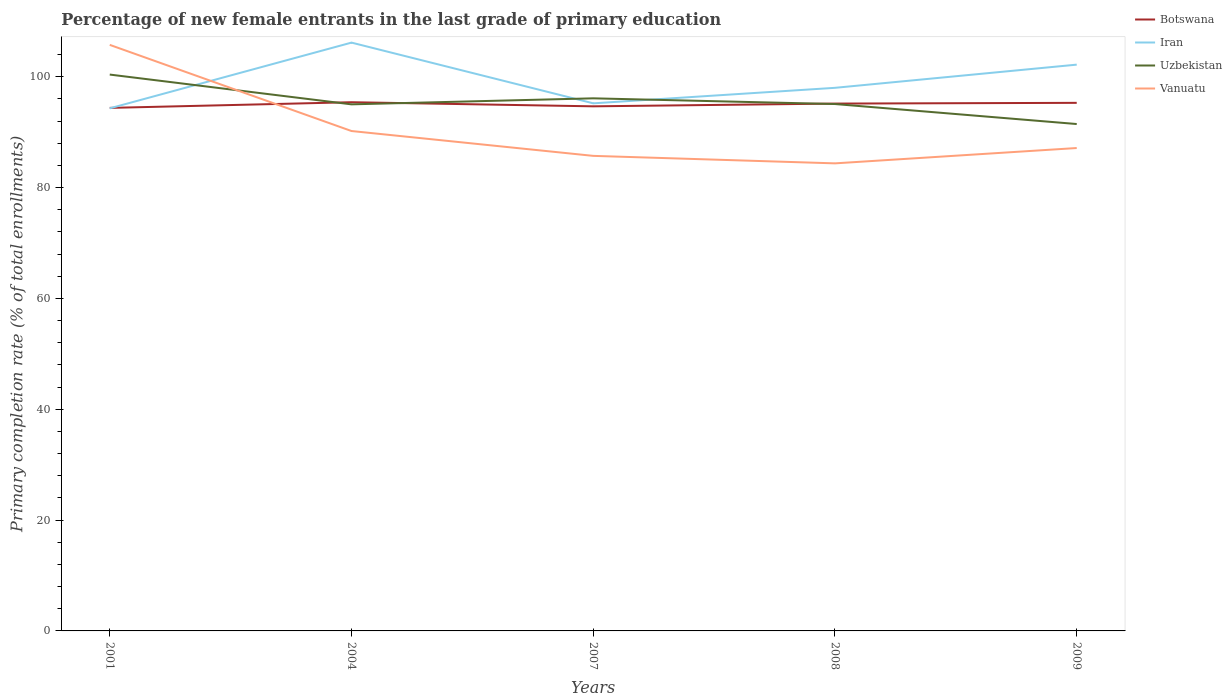Is the number of lines equal to the number of legend labels?
Offer a terse response. Yes. Across all years, what is the maximum percentage of new female entrants in Botswana?
Keep it short and to the point. 94.38. In which year was the percentage of new female entrants in Botswana maximum?
Give a very brief answer. 2001. What is the total percentage of new female entrants in Uzbekistan in the graph?
Your answer should be very brief. -1.09. What is the difference between the highest and the second highest percentage of new female entrants in Vanuatu?
Ensure brevity in your answer.  21.38. What is the difference between the highest and the lowest percentage of new female entrants in Uzbekistan?
Offer a terse response. 2. Is the percentage of new female entrants in Iran strictly greater than the percentage of new female entrants in Botswana over the years?
Make the answer very short. No. What is the difference between two consecutive major ticks on the Y-axis?
Your answer should be very brief. 20. Are the values on the major ticks of Y-axis written in scientific E-notation?
Provide a short and direct response. No. Does the graph contain any zero values?
Give a very brief answer. No. Does the graph contain grids?
Offer a terse response. No. How many legend labels are there?
Offer a terse response. 4. What is the title of the graph?
Provide a short and direct response. Percentage of new female entrants in the last grade of primary education. What is the label or title of the X-axis?
Ensure brevity in your answer.  Years. What is the label or title of the Y-axis?
Provide a short and direct response. Primary completion rate (% of total enrollments). What is the Primary completion rate (% of total enrollments) of Botswana in 2001?
Provide a short and direct response. 94.38. What is the Primary completion rate (% of total enrollments) of Iran in 2001?
Provide a succinct answer. 94.3. What is the Primary completion rate (% of total enrollments) of Uzbekistan in 2001?
Offer a very short reply. 100.4. What is the Primary completion rate (% of total enrollments) of Vanuatu in 2001?
Keep it short and to the point. 105.76. What is the Primary completion rate (% of total enrollments) of Botswana in 2004?
Offer a terse response. 95.41. What is the Primary completion rate (% of total enrollments) in Iran in 2004?
Your response must be concise. 106.16. What is the Primary completion rate (% of total enrollments) in Uzbekistan in 2004?
Provide a short and direct response. 95.02. What is the Primary completion rate (% of total enrollments) of Vanuatu in 2004?
Your answer should be compact. 90.21. What is the Primary completion rate (% of total enrollments) in Botswana in 2007?
Keep it short and to the point. 94.67. What is the Primary completion rate (% of total enrollments) in Iran in 2007?
Give a very brief answer. 95.21. What is the Primary completion rate (% of total enrollments) in Uzbekistan in 2007?
Keep it short and to the point. 96.11. What is the Primary completion rate (% of total enrollments) in Vanuatu in 2007?
Ensure brevity in your answer.  85.73. What is the Primary completion rate (% of total enrollments) in Botswana in 2008?
Give a very brief answer. 95.16. What is the Primary completion rate (% of total enrollments) in Iran in 2008?
Offer a very short reply. 98. What is the Primary completion rate (% of total enrollments) in Uzbekistan in 2008?
Your answer should be very brief. 95.08. What is the Primary completion rate (% of total enrollments) in Vanuatu in 2008?
Provide a short and direct response. 84.37. What is the Primary completion rate (% of total enrollments) in Botswana in 2009?
Offer a very short reply. 95.29. What is the Primary completion rate (% of total enrollments) in Iran in 2009?
Offer a very short reply. 102.19. What is the Primary completion rate (% of total enrollments) in Uzbekistan in 2009?
Keep it short and to the point. 91.47. What is the Primary completion rate (% of total enrollments) of Vanuatu in 2009?
Give a very brief answer. 87.14. Across all years, what is the maximum Primary completion rate (% of total enrollments) of Botswana?
Give a very brief answer. 95.41. Across all years, what is the maximum Primary completion rate (% of total enrollments) of Iran?
Offer a very short reply. 106.16. Across all years, what is the maximum Primary completion rate (% of total enrollments) of Uzbekistan?
Provide a succinct answer. 100.4. Across all years, what is the maximum Primary completion rate (% of total enrollments) in Vanuatu?
Offer a terse response. 105.76. Across all years, what is the minimum Primary completion rate (% of total enrollments) in Botswana?
Provide a short and direct response. 94.38. Across all years, what is the minimum Primary completion rate (% of total enrollments) of Iran?
Make the answer very short. 94.3. Across all years, what is the minimum Primary completion rate (% of total enrollments) of Uzbekistan?
Offer a terse response. 91.47. Across all years, what is the minimum Primary completion rate (% of total enrollments) in Vanuatu?
Your answer should be compact. 84.37. What is the total Primary completion rate (% of total enrollments) in Botswana in the graph?
Ensure brevity in your answer.  474.91. What is the total Primary completion rate (% of total enrollments) in Iran in the graph?
Your answer should be very brief. 495.86. What is the total Primary completion rate (% of total enrollments) of Uzbekistan in the graph?
Provide a short and direct response. 478.08. What is the total Primary completion rate (% of total enrollments) of Vanuatu in the graph?
Ensure brevity in your answer.  453.2. What is the difference between the Primary completion rate (% of total enrollments) in Botswana in 2001 and that in 2004?
Provide a short and direct response. -1.02. What is the difference between the Primary completion rate (% of total enrollments) in Iran in 2001 and that in 2004?
Make the answer very short. -11.86. What is the difference between the Primary completion rate (% of total enrollments) of Uzbekistan in 2001 and that in 2004?
Provide a short and direct response. 5.37. What is the difference between the Primary completion rate (% of total enrollments) of Vanuatu in 2001 and that in 2004?
Make the answer very short. 15.55. What is the difference between the Primary completion rate (% of total enrollments) of Botswana in 2001 and that in 2007?
Your response must be concise. -0.28. What is the difference between the Primary completion rate (% of total enrollments) in Iran in 2001 and that in 2007?
Make the answer very short. -0.9. What is the difference between the Primary completion rate (% of total enrollments) in Uzbekistan in 2001 and that in 2007?
Provide a short and direct response. 4.29. What is the difference between the Primary completion rate (% of total enrollments) of Vanuatu in 2001 and that in 2007?
Your answer should be very brief. 20.03. What is the difference between the Primary completion rate (% of total enrollments) in Botswana in 2001 and that in 2008?
Make the answer very short. -0.78. What is the difference between the Primary completion rate (% of total enrollments) of Iran in 2001 and that in 2008?
Offer a very short reply. -3.7. What is the difference between the Primary completion rate (% of total enrollments) in Uzbekistan in 2001 and that in 2008?
Offer a terse response. 5.32. What is the difference between the Primary completion rate (% of total enrollments) of Vanuatu in 2001 and that in 2008?
Make the answer very short. 21.38. What is the difference between the Primary completion rate (% of total enrollments) in Botswana in 2001 and that in 2009?
Offer a very short reply. -0.91. What is the difference between the Primary completion rate (% of total enrollments) of Iran in 2001 and that in 2009?
Your answer should be very brief. -7.88. What is the difference between the Primary completion rate (% of total enrollments) of Uzbekistan in 2001 and that in 2009?
Give a very brief answer. 8.93. What is the difference between the Primary completion rate (% of total enrollments) in Vanuatu in 2001 and that in 2009?
Your response must be concise. 18.62. What is the difference between the Primary completion rate (% of total enrollments) in Botswana in 2004 and that in 2007?
Your answer should be compact. 0.74. What is the difference between the Primary completion rate (% of total enrollments) in Iran in 2004 and that in 2007?
Keep it short and to the point. 10.96. What is the difference between the Primary completion rate (% of total enrollments) of Uzbekistan in 2004 and that in 2007?
Your answer should be very brief. -1.09. What is the difference between the Primary completion rate (% of total enrollments) in Vanuatu in 2004 and that in 2007?
Your answer should be compact. 4.48. What is the difference between the Primary completion rate (% of total enrollments) of Botswana in 2004 and that in 2008?
Keep it short and to the point. 0.25. What is the difference between the Primary completion rate (% of total enrollments) of Iran in 2004 and that in 2008?
Offer a very short reply. 8.16. What is the difference between the Primary completion rate (% of total enrollments) of Uzbekistan in 2004 and that in 2008?
Keep it short and to the point. -0.06. What is the difference between the Primary completion rate (% of total enrollments) of Vanuatu in 2004 and that in 2008?
Offer a very short reply. 5.84. What is the difference between the Primary completion rate (% of total enrollments) of Botswana in 2004 and that in 2009?
Provide a succinct answer. 0.11. What is the difference between the Primary completion rate (% of total enrollments) of Iran in 2004 and that in 2009?
Offer a terse response. 3.98. What is the difference between the Primary completion rate (% of total enrollments) of Uzbekistan in 2004 and that in 2009?
Your answer should be very brief. 3.55. What is the difference between the Primary completion rate (% of total enrollments) in Vanuatu in 2004 and that in 2009?
Give a very brief answer. 3.07. What is the difference between the Primary completion rate (% of total enrollments) of Botswana in 2007 and that in 2008?
Provide a succinct answer. -0.5. What is the difference between the Primary completion rate (% of total enrollments) of Iran in 2007 and that in 2008?
Keep it short and to the point. -2.8. What is the difference between the Primary completion rate (% of total enrollments) of Uzbekistan in 2007 and that in 2008?
Your answer should be compact. 1.03. What is the difference between the Primary completion rate (% of total enrollments) in Vanuatu in 2007 and that in 2008?
Provide a short and direct response. 1.35. What is the difference between the Primary completion rate (% of total enrollments) of Botswana in 2007 and that in 2009?
Ensure brevity in your answer.  -0.63. What is the difference between the Primary completion rate (% of total enrollments) of Iran in 2007 and that in 2009?
Offer a very short reply. -6.98. What is the difference between the Primary completion rate (% of total enrollments) of Uzbekistan in 2007 and that in 2009?
Provide a short and direct response. 4.64. What is the difference between the Primary completion rate (% of total enrollments) of Vanuatu in 2007 and that in 2009?
Your response must be concise. -1.42. What is the difference between the Primary completion rate (% of total enrollments) of Botswana in 2008 and that in 2009?
Offer a terse response. -0.13. What is the difference between the Primary completion rate (% of total enrollments) of Iran in 2008 and that in 2009?
Make the answer very short. -4.18. What is the difference between the Primary completion rate (% of total enrollments) in Uzbekistan in 2008 and that in 2009?
Give a very brief answer. 3.61. What is the difference between the Primary completion rate (% of total enrollments) of Vanuatu in 2008 and that in 2009?
Offer a terse response. -2.77. What is the difference between the Primary completion rate (% of total enrollments) in Botswana in 2001 and the Primary completion rate (% of total enrollments) in Iran in 2004?
Ensure brevity in your answer.  -11.78. What is the difference between the Primary completion rate (% of total enrollments) of Botswana in 2001 and the Primary completion rate (% of total enrollments) of Uzbekistan in 2004?
Keep it short and to the point. -0.64. What is the difference between the Primary completion rate (% of total enrollments) of Botswana in 2001 and the Primary completion rate (% of total enrollments) of Vanuatu in 2004?
Ensure brevity in your answer.  4.17. What is the difference between the Primary completion rate (% of total enrollments) in Iran in 2001 and the Primary completion rate (% of total enrollments) in Uzbekistan in 2004?
Make the answer very short. -0.72. What is the difference between the Primary completion rate (% of total enrollments) of Iran in 2001 and the Primary completion rate (% of total enrollments) of Vanuatu in 2004?
Your response must be concise. 4.09. What is the difference between the Primary completion rate (% of total enrollments) in Uzbekistan in 2001 and the Primary completion rate (% of total enrollments) in Vanuatu in 2004?
Offer a terse response. 10.19. What is the difference between the Primary completion rate (% of total enrollments) in Botswana in 2001 and the Primary completion rate (% of total enrollments) in Iran in 2007?
Make the answer very short. -0.82. What is the difference between the Primary completion rate (% of total enrollments) of Botswana in 2001 and the Primary completion rate (% of total enrollments) of Uzbekistan in 2007?
Make the answer very short. -1.72. What is the difference between the Primary completion rate (% of total enrollments) of Botswana in 2001 and the Primary completion rate (% of total enrollments) of Vanuatu in 2007?
Offer a terse response. 8.66. What is the difference between the Primary completion rate (% of total enrollments) in Iran in 2001 and the Primary completion rate (% of total enrollments) in Uzbekistan in 2007?
Keep it short and to the point. -1.8. What is the difference between the Primary completion rate (% of total enrollments) of Iran in 2001 and the Primary completion rate (% of total enrollments) of Vanuatu in 2007?
Keep it short and to the point. 8.58. What is the difference between the Primary completion rate (% of total enrollments) in Uzbekistan in 2001 and the Primary completion rate (% of total enrollments) in Vanuatu in 2007?
Keep it short and to the point. 14.67. What is the difference between the Primary completion rate (% of total enrollments) in Botswana in 2001 and the Primary completion rate (% of total enrollments) in Iran in 2008?
Provide a short and direct response. -3.62. What is the difference between the Primary completion rate (% of total enrollments) of Botswana in 2001 and the Primary completion rate (% of total enrollments) of Uzbekistan in 2008?
Your answer should be compact. -0.7. What is the difference between the Primary completion rate (% of total enrollments) in Botswana in 2001 and the Primary completion rate (% of total enrollments) in Vanuatu in 2008?
Give a very brief answer. 10.01. What is the difference between the Primary completion rate (% of total enrollments) of Iran in 2001 and the Primary completion rate (% of total enrollments) of Uzbekistan in 2008?
Your answer should be very brief. -0.78. What is the difference between the Primary completion rate (% of total enrollments) of Iran in 2001 and the Primary completion rate (% of total enrollments) of Vanuatu in 2008?
Ensure brevity in your answer.  9.93. What is the difference between the Primary completion rate (% of total enrollments) of Uzbekistan in 2001 and the Primary completion rate (% of total enrollments) of Vanuatu in 2008?
Offer a terse response. 16.02. What is the difference between the Primary completion rate (% of total enrollments) of Botswana in 2001 and the Primary completion rate (% of total enrollments) of Iran in 2009?
Provide a short and direct response. -7.8. What is the difference between the Primary completion rate (% of total enrollments) of Botswana in 2001 and the Primary completion rate (% of total enrollments) of Uzbekistan in 2009?
Provide a succinct answer. 2.91. What is the difference between the Primary completion rate (% of total enrollments) in Botswana in 2001 and the Primary completion rate (% of total enrollments) in Vanuatu in 2009?
Ensure brevity in your answer.  7.24. What is the difference between the Primary completion rate (% of total enrollments) in Iran in 2001 and the Primary completion rate (% of total enrollments) in Uzbekistan in 2009?
Provide a succinct answer. 2.83. What is the difference between the Primary completion rate (% of total enrollments) in Iran in 2001 and the Primary completion rate (% of total enrollments) in Vanuatu in 2009?
Ensure brevity in your answer.  7.16. What is the difference between the Primary completion rate (% of total enrollments) of Uzbekistan in 2001 and the Primary completion rate (% of total enrollments) of Vanuatu in 2009?
Offer a terse response. 13.26. What is the difference between the Primary completion rate (% of total enrollments) of Botswana in 2004 and the Primary completion rate (% of total enrollments) of Iran in 2007?
Ensure brevity in your answer.  0.2. What is the difference between the Primary completion rate (% of total enrollments) in Botswana in 2004 and the Primary completion rate (% of total enrollments) in Uzbekistan in 2007?
Offer a terse response. -0.7. What is the difference between the Primary completion rate (% of total enrollments) of Botswana in 2004 and the Primary completion rate (% of total enrollments) of Vanuatu in 2007?
Provide a succinct answer. 9.68. What is the difference between the Primary completion rate (% of total enrollments) in Iran in 2004 and the Primary completion rate (% of total enrollments) in Uzbekistan in 2007?
Your answer should be compact. 10.06. What is the difference between the Primary completion rate (% of total enrollments) in Iran in 2004 and the Primary completion rate (% of total enrollments) in Vanuatu in 2007?
Offer a terse response. 20.44. What is the difference between the Primary completion rate (% of total enrollments) in Uzbekistan in 2004 and the Primary completion rate (% of total enrollments) in Vanuatu in 2007?
Ensure brevity in your answer.  9.3. What is the difference between the Primary completion rate (% of total enrollments) in Botswana in 2004 and the Primary completion rate (% of total enrollments) in Iran in 2008?
Provide a short and direct response. -2.6. What is the difference between the Primary completion rate (% of total enrollments) of Botswana in 2004 and the Primary completion rate (% of total enrollments) of Uzbekistan in 2008?
Provide a succinct answer. 0.33. What is the difference between the Primary completion rate (% of total enrollments) in Botswana in 2004 and the Primary completion rate (% of total enrollments) in Vanuatu in 2008?
Make the answer very short. 11.03. What is the difference between the Primary completion rate (% of total enrollments) of Iran in 2004 and the Primary completion rate (% of total enrollments) of Uzbekistan in 2008?
Offer a very short reply. 11.08. What is the difference between the Primary completion rate (% of total enrollments) in Iran in 2004 and the Primary completion rate (% of total enrollments) in Vanuatu in 2008?
Offer a terse response. 21.79. What is the difference between the Primary completion rate (% of total enrollments) of Uzbekistan in 2004 and the Primary completion rate (% of total enrollments) of Vanuatu in 2008?
Offer a very short reply. 10.65. What is the difference between the Primary completion rate (% of total enrollments) of Botswana in 2004 and the Primary completion rate (% of total enrollments) of Iran in 2009?
Make the answer very short. -6.78. What is the difference between the Primary completion rate (% of total enrollments) of Botswana in 2004 and the Primary completion rate (% of total enrollments) of Uzbekistan in 2009?
Your answer should be compact. 3.94. What is the difference between the Primary completion rate (% of total enrollments) of Botswana in 2004 and the Primary completion rate (% of total enrollments) of Vanuatu in 2009?
Your response must be concise. 8.27. What is the difference between the Primary completion rate (% of total enrollments) of Iran in 2004 and the Primary completion rate (% of total enrollments) of Uzbekistan in 2009?
Provide a short and direct response. 14.69. What is the difference between the Primary completion rate (% of total enrollments) of Iran in 2004 and the Primary completion rate (% of total enrollments) of Vanuatu in 2009?
Provide a short and direct response. 19.02. What is the difference between the Primary completion rate (% of total enrollments) of Uzbekistan in 2004 and the Primary completion rate (% of total enrollments) of Vanuatu in 2009?
Ensure brevity in your answer.  7.88. What is the difference between the Primary completion rate (% of total enrollments) in Botswana in 2007 and the Primary completion rate (% of total enrollments) in Iran in 2008?
Offer a terse response. -3.34. What is the difference between the Primary completion rate (% of total enrollments) of Botswana in 2007 and the Primary completion rate (% of total enrollments) of Uzbekistan in 2008?
Provide a succinct answer. -0.41. What is the difference between the Primary completion rate (% of total enrollments) in Botswana in 2007 and the Primary completion rate (% of total enrollments) in Vanuatu in 2008?
Your response must be concise. 10.29. What is the difference between the Primary completion rate (% of total enrollments) in Iran in 2007 and the Primary completion rate (% of total enrollments) in Uzbekistan in 2008?
Ensure brevity in your answer.  0.13. What is the difference between the Primary completion rate (% of total enrollments) of Iran in 2007 and the Primary completion rate (% of total enrollments) of Vanuatu in 2008?
Your answer should be very brief. 10.83. What is the difference between the Primary completion rate (% of total enrollments) of Uzbekistan in 2007 and the Primary completion rate (% of total enrollments) of Vanuatu in 2008?
Provide a succinct answer. 11.73. What is the difference between the Primary completion rate (% of total enrollments) in Botswana in 2007 and the Primary completion rate (% of total enrollments) in Iran in 2009?
Make the answer very short. -7.52. What is the difference between the Primary completion rate (% of total enrollments) in Botswana in 2007 and the Primary completion rate (% of total enrollments) in Uzbekistan in 2009?
Provide a succinct answer. 3.2. What is the difference between the Primary completion rate (% of total enrollments) in Botswana in 2007 and the Primary completion rate (% of total enrollments) in Vanuatu in 2009?
Provide a short and direct response. 7.52. What is the difference between the Primary completion rate (% of total enrollments) in Iran in 2007 and the Primary completion rate (% of total enrollments) in Uzbekistan in 2009?
Ensure brevity in your answer.  3.74. What is the difference between the Primary completion rate (% of total enrollments) of Iran in 2007 and the Primary completion rate (% of total enrollments) of Vanuatu in 2009?
Give a very brief answer. 8.06. What is the difference between the Primary completion rate (% of total enrollments) of Uzbekistan in 2007 and the Primary completion rate (% of total enrollments) of Vanuatu in 2009?
Make the answer very short. 8.97. What is the difference between the Primary completion rate (% of total enrollments) of Botswana in 2008 and the Primary completion rate (% of total enrollments) of Iran in 2009?
Your answer should be compact. -7.03. What is the difference between the Primary completion rate (% of total enrollments) in Botswana in 2008 and the Primary completion rate (% of total enrollments) in Uzbekistan in 2009?
Give a very brief answer. 3.69. What is the difference between the Primary completion rate (% of total enrollments) of Botswana in 2008 and the Primary completion rate (% of total enrollments) of Vanuatu in 2009?
Provide a succinct answer. 8.02. What is the difference between the Primary completion rate (% of total enrollments) in Iran in 2008 and the Primary completion rate (% of total enrollments) in Uzbekistan in 2009?
Make the answer very short. 6.53. What is the difference between the Primary completion rate (% of total enrollments) of Iran in 2008 and the Primary completion rate (% of total enrollments) of Vanuatu in 2009?
Your answer should be very brief. 10.86. What is the difference between the Primary completion rate (% of total enrollments) in Uzbekistan in 2008 and the Primary completion rate (% of total enrollments) in Vanuatu in 2009?
Your answer should be very brief. 7.94. What is the average Primary completion rate (% of total enrollments) of Botswana per year?
Provide a short and direct response. 94.98. What is the average Primary completion rate (% of total enrollments) of Iran per year?
Ensure brevity in your answer.  99.17. What is the average Primary completion rate (% of total enrollments) in Uzbekistan per year?
Make the answer very short. 95.62. What is the average Primary completion rate (% of total enrollments) of Vanuatu per year?
Keep it short and to the point. 90.64. In the year 2001, what is the difference between the Primary completion rate (% of total enrollments) of Botswana and Primary completion rate (% of total enrollments) of Iran?
Offer a terse response. 0.08. In the year 2001, what is the difference between the Primary completion rate (% of total enrollments) of Botswana and Primary completion rate (% of total enrollments) of Uzbekistan?
Offer a terse response. -6.01. In the year 2001, what is the difference between the Primary completion rate (% of total enrollments) in Botswana and Primary completion rate (% of total enrollments) in Vanuatu?
Offer a very short reply. -11.37. In the year 2001, what is the difference between the Primary completion rate (% of total enrollments) in Iran and Primary completion rate (% of total enrollments) in Uzbekistan?
Give a very brief answer. -6.09. In the year 2001, what is the difference between the Primary completion rate (% of total enrollments) of Iran and Primary completion rate (% of total enrollments) of Vanuatu?
Ensure brevity in your answer.  -11.45. In the year 2001, what is the difference between the Primary completion rate (% of total enrollments) in Uzbekistan and Primary completion rate (% of total enrollments) in Vanuatu?
Give a very brief answer. -5.36. In the year 2004, what is the difference between the Primary completion rate (% of total enrollments) in Botswana and Primary completion rate (% of total enrollments) in Iran?
Provide a short and direct response. -10.76. In the year 2004, what is the difference between the Primary completion rate (% of total enrollments) of Botswana and Primary completion rate (% of total enrollments) of Uzbekistan?
Your response must be concise. 0.38. In the year 2004, what is the difference between the Primary completion rate (% of total enrollments) of Botswana and Primary completion rate (% of total enrollments) of Vanuatu?
Provide a short and direct response. 5.2. In the year 2004, what is the difference between the Primary completion rate (% of total enrollments) of Iran and Primary completion rate (% of total enrollments) of Uzbekistan?
Offer a very short reply. 11.14. In the year 2004, what is the difference between the Primary completion rate (% of total enrollments) in Iran and Primary completion rate (% of total enrollments) in Vanuatu?
Your response must be concise. 15.95. In the year 2004, what is the difference between the Primary completion rate (% of total enrollments) of Uzbekistan and Primary completion rate (% of total enrollments) of Vanuatu?
Your answer should be compact. 4.81. In the year 2007, what is the difference between the Primary completion rate (% of total enrollments) in Botswana and Primary completion rate (% of total enrollments) in Iran?
Offer a terse response. -0.54. In the year 2007, what is the difference between the Primary completion rate (% of total enrollments) in Botswana and Primary completion rate (% of total enrollments) in Uzbekistan?
Provide a short and direct response. -1.44. In the year 2007, what is the difference between the Primary completion rate (% of total enrollments) of Botswana and Primary completion rate (% of total enrollments) of Vanuatu?
Give a very brief answer. 8.94. In the year 2007, what is the difference between the Primary completion rate (% of total enrollments) in Iran and Primary completion rate (% of total enrollments) in Uzbekistan?
Offer a very short reply. -0.9. In the year 2007, what is the difference between the Primary completion rate (% of total enrollments) in Iran and Primary completion rate (% of total enrollments) in Vanuatu?
Ensure brevity in your answer.  9.48. In the year 2007, what is the difference between the Primary completion rate (% of total enrollments) of Uzbekistan and Primary completion rate (% of total enrollments) of Vanuatu?
Provide a short and direct response. 10.38. In the year 2008, what is the difference between the Primary completion rate (% of total enrollments) of Botswana and Primary completion rate (% of total enrollments) of Iran?
Offer a terse response. -2.84. In the year 2008, what is the difference between the Primary completion rate (% of total enrollments) in Botswana and Primary completion rate (% of total enrollments) in Uzbekistan?
Your answer should be very brief. 0.08. In the year 2008, what is the difference between the Primary completion rate (% of total enrollments) of Botswana and Primary completion rate (% of total enrollments) of Vanuatu?
Keep it short and to the point. 10.79. In the year 2008, what is the difference between the Primary completion rate (% of total enrollments) in Iran and Primary completion rate (% of total enrollments) in Uzbekistan?
Provide a succinct answer. 2.92. In the year 2008, what is the difference between the Primary completion rate (% of total enrollments) of Iran and Primary completion rate (% of total enrollments) of Vanuatu?
Give a very brief answer. 13.63. In the year 2008, what is the difference between the Primary completion rate (% of total enrollments) of Uzbekistan and Primary completion rate (% of total enrollments) of Vanuatu?
Ensure brevity in your answer.  10.71. In the year 2009, what is the difference between the Primary completion rate (% of total enrollments) in Botswana and Primary completion rate (% of total enrollments) in Iran?
Provide a succinct answer. -6.89. In the year 2009, what is the difference between the Primary completion rate (% of total enrollments) of Botswana and Primary completion rate (% of total enrollments) of Uzbekistan?
Your answer should be compact. 3.82. In the year 2009, what is the difference between the Primary completion rate (% of total enrollments) in Botswana and Primary completion rate (% of total enrollments) in Vanuatu?
Offer a terse response. 8.15. In the year 2009, what is the difference between the Primary completion rate (% of total enrollments) of Iran and Primary completion rate (% of total enrollments) of Uzbekistan?
Your answer should be very brief. 10.72. In the year 2009, what is the difference between the Primary completion rate (% of total enrollments) in Iran and Primary completion rate (% of total enrollments) in Vanuatu?
Keep it short and to the point. 15.05. In the year 2009, what is the difference between the Primary completion rate (% of total enrollments) in Uzbekistan and Primary completion rate (% of total enrollments) in Vanuatu?
Offer a terse response. 4.33. What is the ratio of the Primary completion rate (% of total enrollments) of Botswana in 2001 to that in 2004?
Your response must be concise. 0.99. What is the ratio of the Primary completion rate (% of total enrollments) of Iran in 2001 to that in 2004?
Ensure brevity in your answer.  0.89. What is the ratio of the Primary completion rate (% of total enrollments) in Uzbekistan in 2001 to that in 2004?
Your answer should be compact. 1.06. What is the ratio of the Primary completion rate (% of total enrollments) of Vanuatu in 2001 to that in 2004?
Give a very brief answer. 1.17. What is the ratio of the Primary completion rate (% of total enrollments) of Uzbekistan in 2001 to that in 2007?
Make the answer very short. 1.04. What is the ratio of the Primary completion rate (% of total enrollments) in Vanuatu in 2001 to that in 2007?
Make the answer very short. 1.23. What is the ratio of the Primary completion rate (% of total enrollments) in Iran in 2001 to that in 2008?
Provide a short and direct response. 0.96. What is the ratio of the Primary completion rate (% of total enrollments) of Uzbekistan in 2001 to that in 2008?
Offer a very short reply. 1.06. What is the ratio of the Primary completion rate (% of total enrollments) in Vanuatu in 2001 to that in 2008?
Your answer should be very brief. 1.25. What is the ratio of the Primary completion rate (% of total enrollments) of Botswana in 2001 to that in 2009?
Your answer should be compact. 0.99. What is the ratio of the Primary completion rate (% of total enrollments) in Iran in 2001 to that in 2009?
Your answer should be compact. 0.92. What is the ratio of the Primary completion rate (% of total enrollments) in Uzbekistan in 2001 to that in 2009?
Ensure brevity in your answer.  1.1. What is the ratio of the Primary completion rate (% of total enrollments) in Vanuatu in 2001 to that in 2009?
Offer a very short reply. 1.21. What is the ratio of the Primary completion rate (% of total enrollments) of Iran in 2004 to that in 2007?
Your response must be concise. 1.12. What is the ratio of the Primary completion rate (% of total enrollments) in Uzbekistan in 2004 to that in 2007?
Provide a short and direct response. 0.99. What is the ratio of the Primary completion rate (% of total enrollments) of Vanuatu in 2004 to that in 2007?
Ensure brevity in your answer.  1.05. What is the ratio of the Primary completion rate (% of total enrollments) of Iran in 2004 to that in 2008?
Your answer should be compact. 1.08. What is the ratio of the Primary completion rate (% of total enrollments) of Vanuatu in 2004 to that in 2008?
Your answer should be very brief. 1.07. What is the ratio of the Primary completion rate (% of total enrollments) of Iran in 2004 to that in 2009?
Keep it short and to the point. 1.04. What is the ratio of the Primary completion rate (% of total enrollments) in Uzbekistan in 2004 to that in 2009?
Provide a short and direct response. 1.04. What is the ratio of the Primary completion rate (% of total enrollments) of Vanuatu in 2004 to that in 2009?
Your response must be concise. 1.04. What is the ratio of the Primary completion rate (% of total enrollments) of Iran in 2007 to that in 2008?
Give a very brief answer. 0.97. What is the ratio of the Primary completion rate (% of total enrollments) of Uzbekistan in 2007 to that in 2008?
Give a very brief answer. 1.01. What is the ratio of the Primary completion rate (% of total enrollments) of Botswana in 2007 to that in 2009?
Offer a terse response. 0.99. What is the ratio of the Primary completion rate (% of total enrollments) in Iran in 2007 to that in 2009?
Give a very brief answer. 0.93. What is the ratio of the Primary completion rate (% of total enrollments) of Uzbekistan in 2007 to that in 2009?
Provide a short and direct response. 1.05. What is the ratio of the Primary completion rate (% of total enrollments) of Vanuatu in 2007 to that in 2009?
Offer a very short reply. 0.98. What is the ratio of the Primary completion rate (% of total enrollments) in Iran in 2008 to that in 2009?
Provide a succinct answer. 0.96. What is the ratio of the Primary completion rate (% of total enrollments) of Uzbekistan in 2008 to that in 2009?
Make the answer very short. 1.04. What is the ratio of the Primary completion rate (% of total enrollments) in Vanuatu in 2008 to that in 2009?
Your answer should be very brief. 0.97. What is the difference between the highest and the second highest Primary completion rate (% of total enrollments) in Botswana?
Provide a succinct answer. 0.11. What is the difference between the highest and the second highest Primary completion rate (% of total enrollments) of Iran?
Your response must be concise. 3.98. What is the difference between the highest and the second highest Primary completion rate (% of total enrollments) in Uzbekistan?
Offer a terse response. 4.29. What is the difference between the highest and the second highest Primary completion rate (% of total enrollments) in Vanuatu?
Offer a terse response. 15.55. What is the difference between the highest and the lowest Primary completion rate (% of total enrollments) in Botswana?
Offer a very short reply. 1.02. What is the difference between the highest and the lowest Primary completion rate (% of total enrollments) of Iran?
Your answer should be compact. 11.86. What is the difference between the highest and the lowest Primary completion rate (% of total enrollments) in Uzbekistan?
Provide a succinct answer. 8.93. What is the difference between the highest and the lowest Primary completion rate (% of total enrollments) of Vanuatu?
Provide a succinct answer. 21.38. 